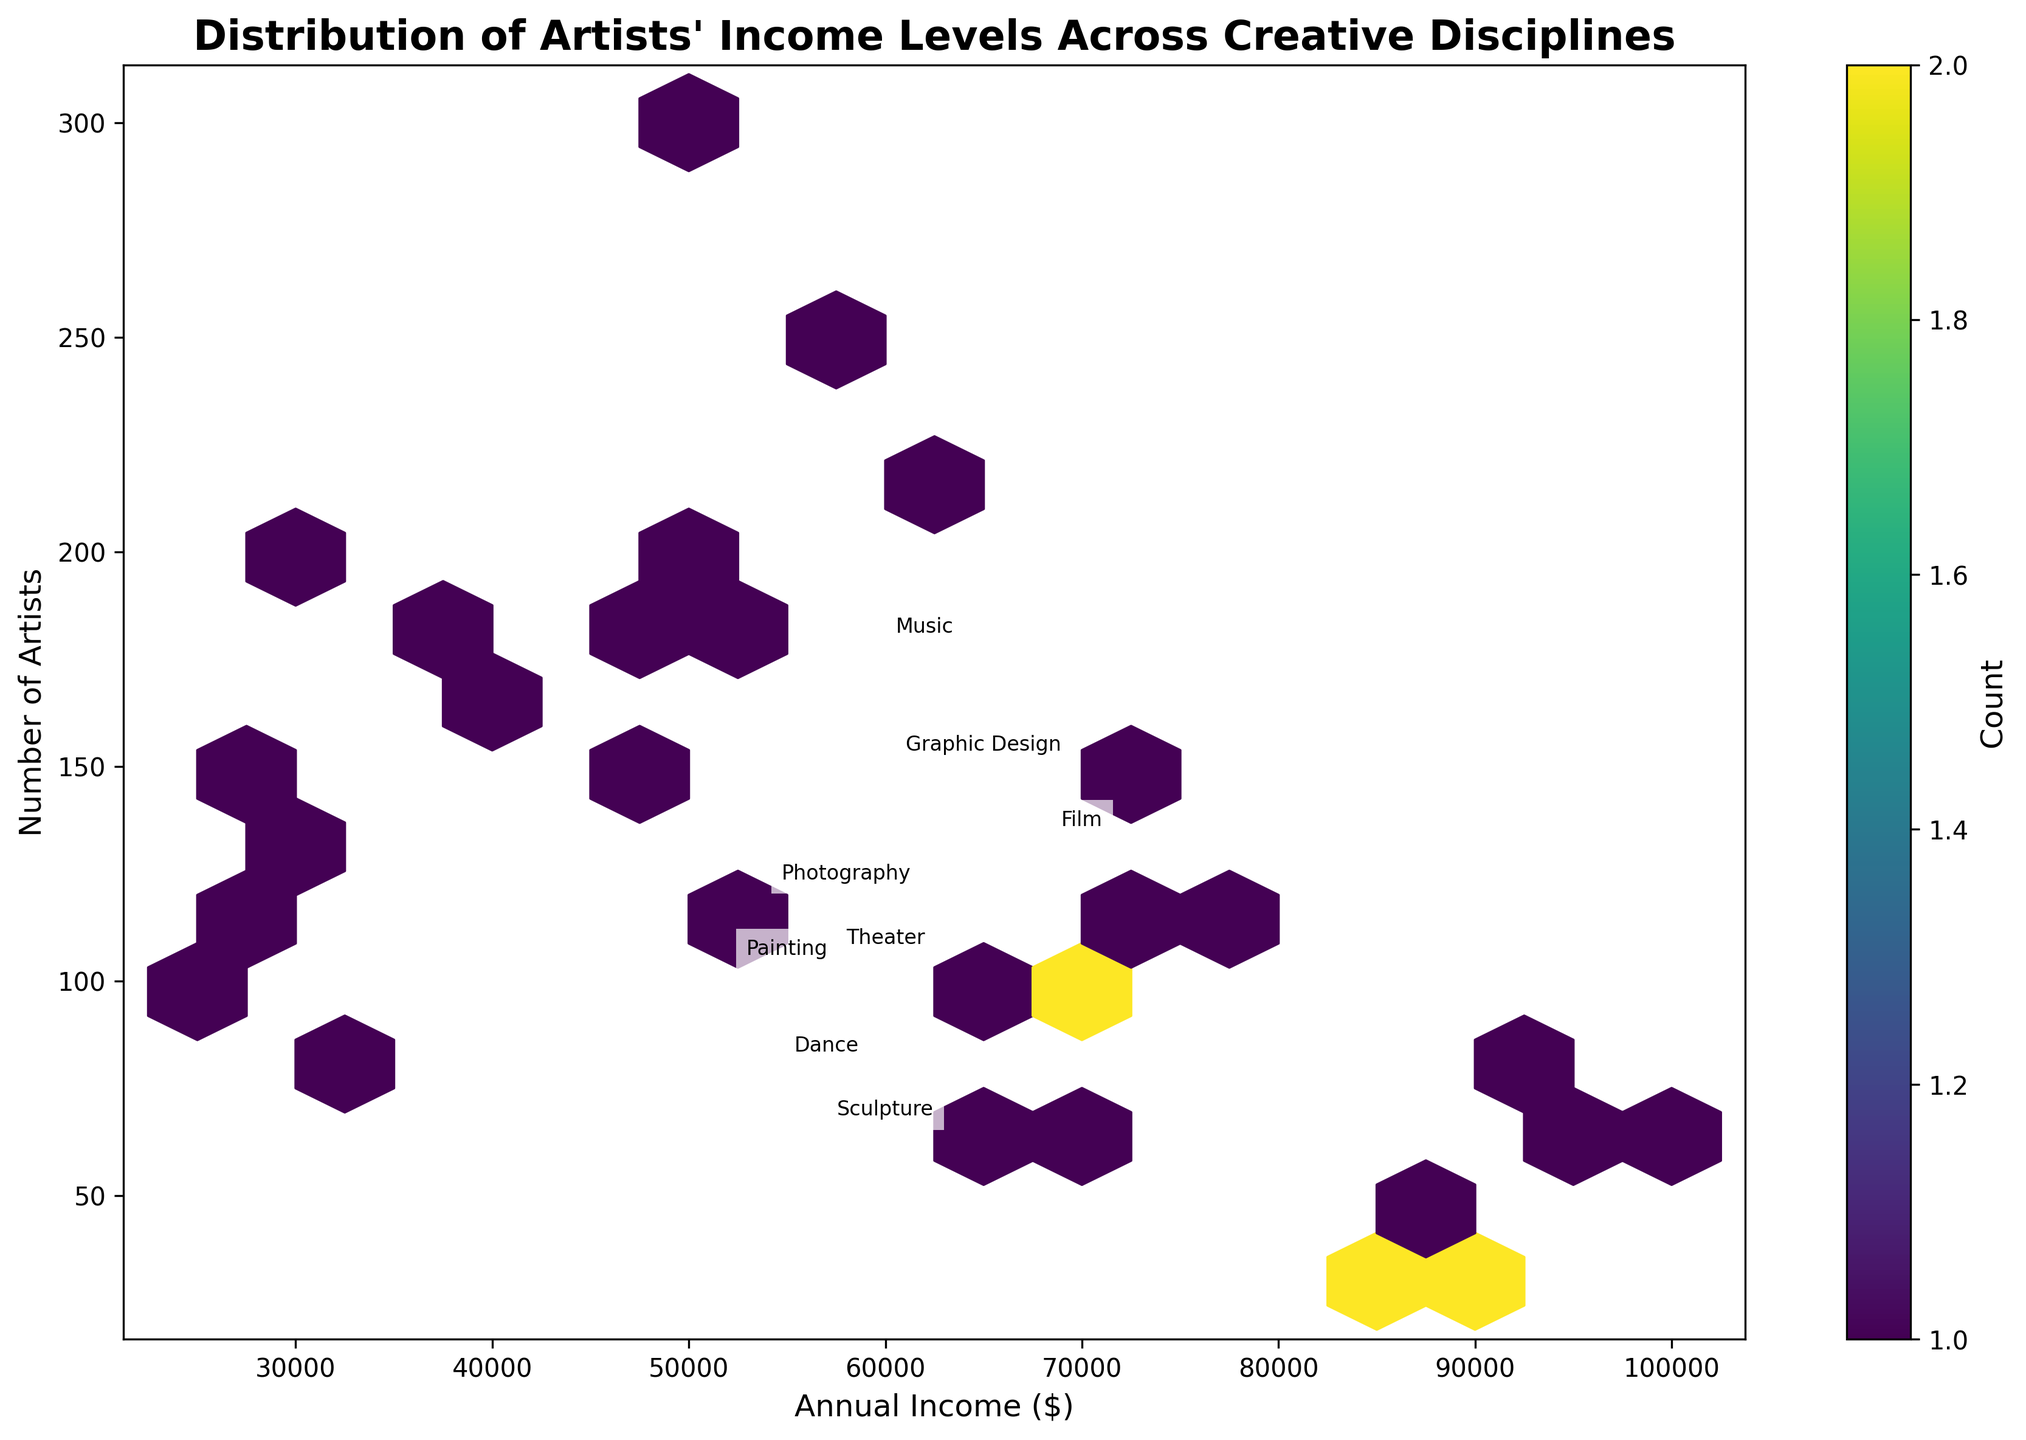Is there any overlap in the income levels across different disciplines? The figure uses hexbin to show the distribution, and different disciplines overlap in some regions, indicating similar income levels. For example, several disciplines fall within the $30,000 to $50,000 range with varying artist numbers.
Answer: Yes How many artists are in the income range of $50,000 to $70,000 in Painting? Referring to the hexbin plot, identify the area on the horizontal axis between $50,000 and $70,000 for Painting and observe the number of artists represented by the density and color gradient. The number of artists here is the combination of the fat points around the range $50,000 to $70,000 for Painting.
Answer: Approximately 180 Which discipline has the highest number of artists at the highest income level? In the hexbin plot, look for the tallest hexagons on the right side of the plot indicating the discipline and artist count. Photography, which has a considerable number of artists (around 50) at the $88,000 income level, is visible.
Answer: Photography What is the average annual income of artists across all disciplines? To find the average, calculate the midpoint for each income range across all disciplines, then sum these averages and divide by the count of art types (e.g., Painting, Sculpture, etc.). Values would be approximations taken from visually average data points for each hexagon concentration.
Answer: Roughly $61,200 Compare the income distributions of Music and Dance. Which one shows a broader spread? Look at how wide the income distributions stretch for both categories on the hexbin plot. Music spreads from $32,000 to $92,000, while Dance spreads from $27,000 to $87,000. Then, compare the density and frequency.
Answer: Music Which discipline has a higher density of artists earning around $50,000? Identify the hexagon representing $50,000 on the horizontal axis and compare the color intensity (density) of hexagons across disciplines. Both Music and Graphic Design show high density, but Graphic Design seems slightly higher.
Answer: Graphic Design What sector shows the least number of artists across all displayed income levels? The least dense discipline will show the faintest colors or sparsest hexagons across the range. Dance shows fewer and lighter hexagons compared to others.
Answer: Dance 